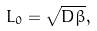Convert formula to latex. <formula><loc_0><loc_0><loc_500><loc_500>L _ { 0 } = \sqrt { D \beta } ,</formula> 